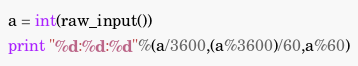Convert code to text. <code><loc_0><loc_0><loc_500><loc_500><_Python_>a = int(raw_input())
print "%d:%d:%d"%(a/3600,(a%3600)/60,a%60)
</code> 